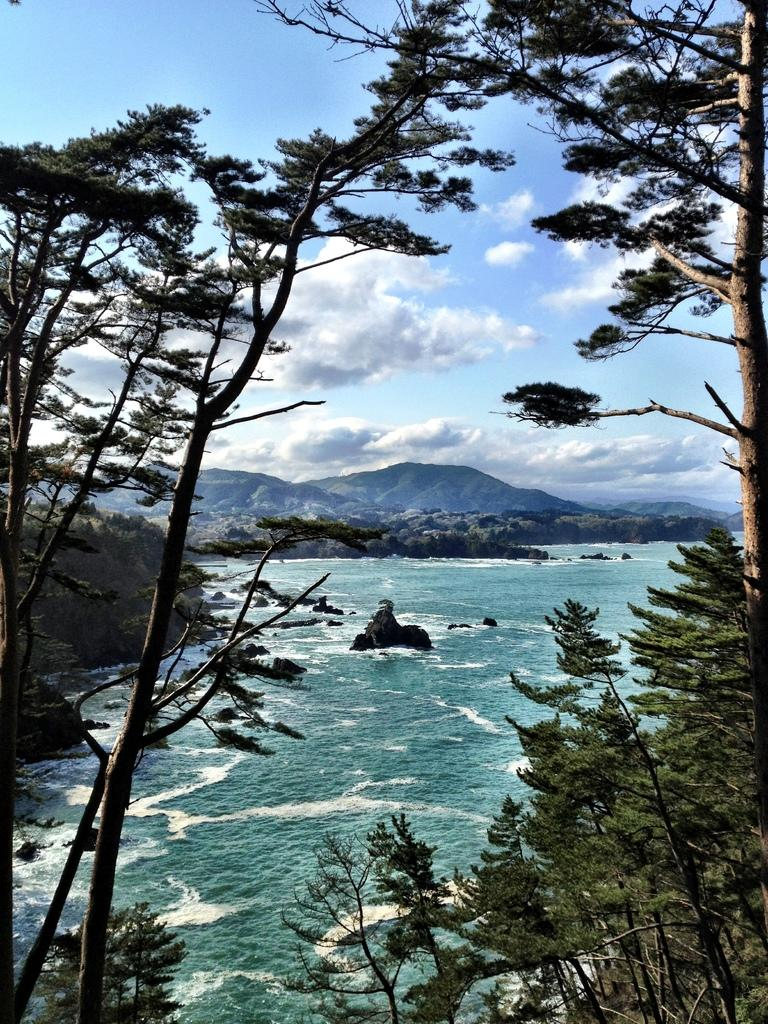What type of vegetation can be seen in the image? There are trees in the image. What natural element is visible in the image? There is water visible in the image. What can be seen in the background of the image? There are hills and the sky visible in the background of the image. What is the condition of the sky in the image? Clouds are present in the sky. Can you tell me how many hens are swimming in the water in the image? There are no hens present in the image, and the water is not depicted as being used for swimming. 